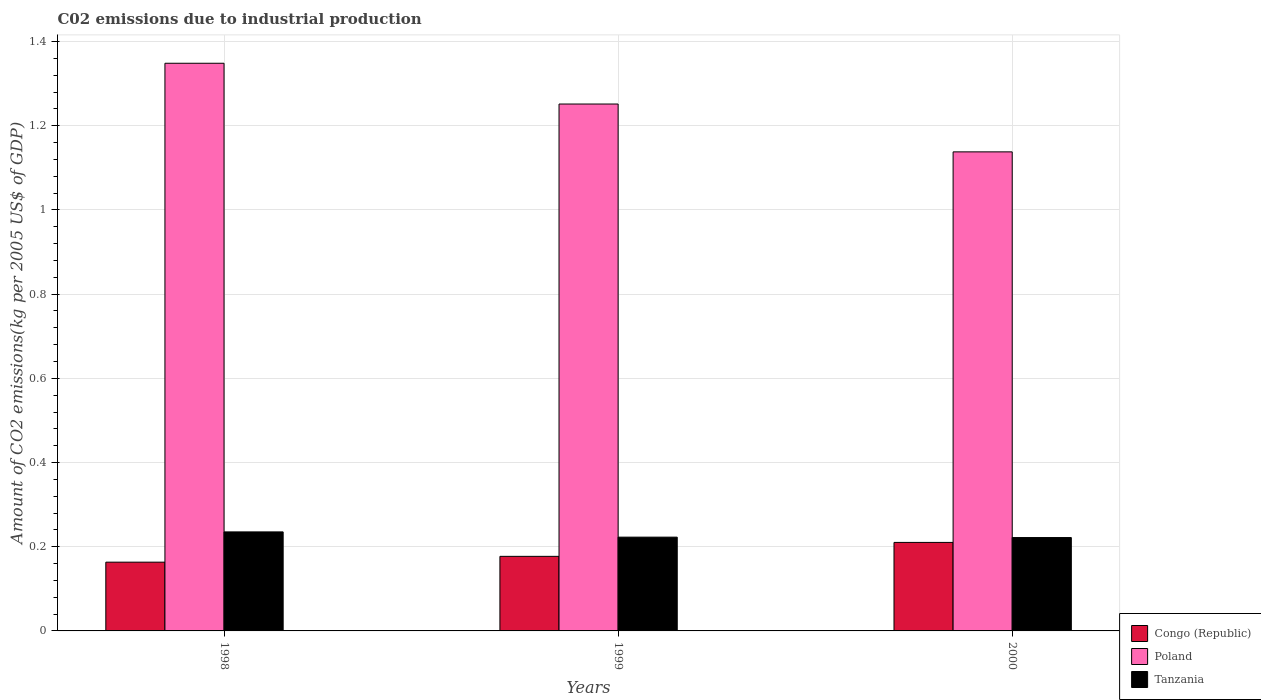Are the number of bars on each tick of the X-axis equal?
Provide a short and direct response. Yes. How many bars are there on the 3rd tick from the right?
Your answer should be compact. 3. What is the amount of CO2 emitted due to industrial production in Poland in 1999?
Offer a terse response. 1.25. Across all years, what is the maximum amount of CO2 emitted due to industrial production in Poland?
Make the answer very short. 1.35. Across all years, what is the minimum amount of CO2 emitted due to industrial production in Poland?
Make the answer very short. 1.14. What is the total amount of CO2 emitted due to industrial production in Tanzania in the graph?
Give a very brief answer. 0.68. What is the difference between the amount of CO2 emitted due to industrial production in Poland in 1998 and that in 1999?
Your answer should be compact. 0.1. What is the difference between the amount of CO2 emitted due to industrial production in Congo (Republic) in 2000 and the amount of CO2 emitted due to industrial production in Poland in 1998?
Provide a short and direct response. -1.14. What is the average amount of CO2 emitted due to industrial production in Poland per year?
Your response must be concise. 1.25. In the year 2000, what is the difference between the amount of CO2 emitted due to industrial production in Tanzania and amount of CO2 emitted due to industrial production in Poland?
Provide a succinct answer. -0.92. In how many years, is the amount of CO2 emitted due to industrial production in Tanzania greater than 0.68 kg?
Ensure brevity in your answer.  0. What is the ratio of the amount of CO2 emitted due to industrial production in Tanzania in 1998 to that in 2000?
Give a very brief answer. 1.06. Is the amount of CO2 emitted due to industrial production in Tanzania in 1998 less than that in 2000?
Ensure brevity in your answer.  No. What is the difference between the highest and the second highest amount of CO2 emitted due to industrial production in Congo (Republic)?
Keep it short and to the point. 0.03. What is the difference between the highest and the lowest amount of CO2 emitted due to industrial production in Tanzania?
Ensure brevity in your answer.  0.01. Is the sum of the amount of CO2 emitted due to industrial production in Poland in 1999 and 2000 greater than the maximum amount of CO2 emitted due to industrial production in Congo (Republic) across all years?
Give a very brief answer. Yes. What does the 1st bar from the left in 1999 represents?
Your answer should be very brief. Congo (Republic). What does the 1st bar from the right in 1998 represents?
Keep it short and to the point. Tanzania. Is it the case that in every year, the sum of the amount of CO2 emitted due to industrial production in Poland and amount of CO2 emitted due to industrial production in Congo (Republic) is greater than the amount of CO2 emitted due to industrial production in Tanzania?
Make the answer very short. Yes. How many bars are there?
Offer a very short reply. 9. How many years are there in the graph?
Give a very brief answer. 3. Does the graph contain any zero values?
Offer a terse response. No. Does the graph contain grids?
Provide a short and direct response. Yes. What is the title of the graph?
Provide a succinct answer. C02 emissions due to industrial production. What is the label or title of the X-axis?
Your answer should be compact. Years. What is the label or title of the Y-axis?
Make the answer very short. Amount of CO2 emissions(kg per 2005 US$ of GDP). What is the Amount of CO2 emissions(kg per 2005 US$ of GDP) in Congo (Republic) in 1998?
Provide a succinct answer. 0.16. What is the Amount of CO2 emissions(kg per 2005 US$ of GDP) of Poland in 1998?
Provide a short and direct response. 1.35. What is the Amount of CO2 emissions(kg per 2005 US$ of GDP) of Tanzania in 1998?
Offer a very short reply. 0.24. What is the Amount of CO2 emissions(kg per 2005 US$ of GDP) of Congo (Republic) in 1999?
Offer a very short reply. 0.18. What is the Amount of CO2 emissions(kg per 2005 US$ of GDP) in Poland in 1999?
Provide a succinct answer. 1.25. What is the Amount of CO2 emissions(kg per 2005 US$ of GDP) of Tanzania in 1999?
Your answer should be compact. 0.22. What is the Amount of CO2 emissions(kg per 2005 US$ of GDP) in Congo (Republic) in 2000?
Make the answer very short. 0.21. What is the Amount of CO2 emissions(kg per 2005 US$ of GDP) of Poland in 2000?
Your answer should be very brief. 1.14. What is the Amount of CO2 emissions(kg per 2005 US$ of GDP) in Tanzania in 2000?
Offer a very short reply. 0.22. Across all years, what is the maximum Amount of CO2 emissions(kg per 2005 US$ of GDP) in Congo (Republic)?
Your response must be concise. 0.21. Across all years, what is the maximum Amount of CO2 emissions(kg per 2005 US$ of GDP) in Poland?
Offer a terse response. 1.35. Across all years, what is the maximum Amount of CO2 emissions(kg per 2005 US$ of GDP) of Tanzania?
Ensure brevity in your answer.  0.24. Across all years, what is the minimum Amount of CO2 emissions(kg per 2005 US$ of GDP) in Congo (Republic)?
Offer a very short reply. 0.16. Across all years, what is the minimum Amount of CO2 emissions(kg per 2005 US$ of GDP) in Poland?
Your answer should be compact. 1.14. Across all years, what is the minimum Amount of CO2 emissions(kg per 2005 US$ of GDP) in Tanzania?
Give a very brief answer. 0.22. What is the total Amount of CO2 emissions(kg per 2005 US$ of GDP) of Congo (Republic) in the graph?
Offer a terse response. 0.55. What is the total Amount of CO2 emissions(kg per 2005 US$ of GDP) in Poland in the graph?
Your answer should be very brief. 3.74. What is the total Amount of CO2 emissions(kg per 2005 US$ of GDP) in Tanzania in the graph?
Your answer should be very brief. 0.68. What is the difference between the Amount of CO2 emissions(kg per 2005 US$ of GDP) in Congo (Republic) in 1998 and that in 1999?
Offer a terse response. -0.01. What is the difference between the Amount of CO2 emissions(kg per 2005 US$ of GDP) in Poland in 1998 and that in 1999?
Provide a succinct answer. 0.1. What is the difference between the Amount of CO2 emissions(kg per 2005 US$ of GDP) of Tanzania in 1998 and that in 1999?
Offer a terse response. 0.01. What is the difference between the Amount of CO2 emissions(kg per 2005 US$ of GDP) in Congo (Republic) in 1998 and that in 2000?
Give a very brief answer. -0.05. What is the difference between the Amount of CO2 emissions(kg per 2005 US$ of GDP) of Poland in 1998 and that in 2000?
Keep it short and to the point. 0.21. What is the difference between the Amount of CO2 emissions(kg per 2005 US$ of GDP) in Tanzania in 1998 and that in 2000?
Keep it short and to the point. 0.01. What is the difference between the Amount of CO2 emissions(kg per 2005 US$ of GDP) of Congo (Republic) in 1999 and that in 2000?
Your answer should be compact. -0.03. What is the difference between the Amount of CO2 emissions(kg per 2005 US$ of GDP) in Poland in 1999 and that in 2000?
Make the answer very short. 0.11. What is the difference between the Amount of CO2 emissions(kg per 2005 US$ of GDP) of Congo (Republic) in 1998 and the Amount of CO2 emissions(kg per 2005 US$ of GDP) of Poland in 1999?
Give a very brief answer. -1.09. What is the difference between the Amount of CO2 emissions(kg per 2005 US$ of GDP) in Congo (Republic) in 1998 and the Amount of CO2 emissions(kg per 2005 US$ of GDP) in Tanzania in 1999?
Offer a terse response. -0.06. What is the difference between the Amount of CO2 emissions(kg per 2005 US$ of GDP) in Poland in 1998 and the Amount of CO2 emissions(kg per 2005 US$ of GDP) in Tanzania in 1999?
Your response must be concise. 1.13. What is the difference between the Amount of CO2 emissions(kg per 2005 US$ of GDP) in Congo (Republic) in 1998 and the Amount of CO2 emissions(kg per 2005 US$ of GDP) in Poland in 2000?
Your answer should be compact. -0.97. What is the difference between the Amount of CO2 emissions(kg per 2005 US$ of GDP) of Congo (Republic) in 1998 and the Amount of CO2 emissions(kg per 2005 US$ of GDP) of Tanzania in 2000?
Your answer should be very brief. -0.06. What is the difference between the Amount of CO2 emissions(kg per 2005 US$ of GDP) in Poland in 1998 and the Amount of CO2 emissions(kg per 2005 US$ of GDP) in Tanzania in 2000?
Your answer should be compact. 1.13. What is the difference between the Amount of CO2 emissions(kg per 2005 US$ of GDP) in Congo (Republic) in 1999 and the Amount of CO2 emissions(kg per 2005 US$ of GDP) in Poland in 2000?
Provide a short and direct response. -0.96. What is the difference between the Amount of CO2 emissions(kg per 2005 US$ of GDP) in Congo (Republic) in 1999 and the Amount of CO2 emissions(kg per 2005 US$ of GDP) in Tanzania in 2000?
Your answer should be compact. -0.04. What is the difference between the Amount of CO2 emissions(kg per 2005 US$ of GDP) in Poland in 1999 and the Amount of CO2 emissions(kg per 2005 US$ of GDP) in Tanzania in 2000?
Your answer should be very brief. 1.03. What is the average Amount of CO2 emissions(kg per 2005 US$ of GDP) of Congo (Republic) per year?
Provide a succinct answer. 0.18. What is the average Amount of CO2 emissions(kg per 2005 US$ of GDP) of Poland per year?
Give a very brief answer. 1.25. What is the average Amount of CO2 emissions(kg per 2005 US$ of GDP) of Tanzania per year?
Provide a short and direct response. 0.23. In the year 1998, what is the difference between the Amount of CO2 emissions(kg per 2005 US$ of GDP) in Congo (Republic) and Amount of CO2 emissions(kg per 2005 US$ of GDP) in Poland?
Keep it short and to the point. -1.19. In the year 1998, what is the difference between the Amount of CO2 emissions(kg per 2005 US$ of GDP) in Congo (Republic) and Amount of CO2 emissions(kg per 2005 US$ of GDP) in Tanzania?
Your answer should be very brief. -0.07. In the year 1998, what is the difference between the Amount of CO2 emissions(kg per 2005 US$ of GDP) of Poland and Amount of CO2 emissions(kg per 2005 US$ of GDP) of Tanzania?
Keep it short and to the point. 1.11. In the year 1999, what is the difference between the Amount of CO2 emissions(kg per 2005 US$ of GDP) of Congo (Republic) and Amount of CO2 emissions(kg per 2005 US$ of GDP) of Poland?
Offer a very short reply. -1.07. In the year 1999, what is the difference between the Amount of CO2 emissions(kg per 2005 US$ of GDP) in Congo (Republic) and Amount of CO2 emissions(kg per 2005 US$ of GDP) in Tanzania?
Your answer should be compact. -0.05. In the year 1999, what is the difference between the Amount of CO2 emissions(kg per 2005 US$ of GDP) in Poland and Amount of CO2 emissions(kg per 2005 US$ of GDP) in Tanzania?
Offer a very short reply. 1.03. In the year 2000, what is the difference between the Amount of CO2 emissions(kg per 2005 US$ of GDP) in Congo (Republic) and Amount of CO2 emissions(kg per 2005 US$ of GDP) in Poland?
Ensure brevity in your answer.  -0.93. In the year 2000, what is the difference between the Amount of CO2 emissions(kg per 2005 US$ of GDP) in Congo (Republic) and Amount of CO2 emissions(kg per 2005 US$ of GDP) in Tanzania?
Offer a very short reply. -0.01. In the year 2000, what is the difference between the Amount of CO2 emissions(kg per 2005 US$ of GDP) in Poland and Amount of CO2 emissions(kg per 2005 US$ of GDP) in Tanzania?
Ensure brevity in your answer.  0.92. What is the ratio of the Amount of CO2 emissions(kg per 2005 US$ of GDP) of Congo (Republic) in 1998 to that in 1999?
Keep it short and to the point. 0.92. What is the ratio of the Amount of CO2 emissions(kg per 2005 US$ of GDP) in Poland in 1998 to that in 1999?
Your answer should be very brief. 1.08. What is the ratio of the Amount of CO2 emissions(kg per 2005 US$ of GDP) of Tanzania in 1998 to that in 1999?
Provide a short and direct response. 1.06. What is the ratio of the Amount of CO2 emissions(kg per 2005 US$ of GDP) in Congo (Republic) in 1998 to that in 2000?
Give a very brief answer. 0.78. What is the ratio of the Amount of CO2 emissions(kg per 2005 US$ of GDP) of Poland in 1998 to that in 2000?
Provide a short and direct response. 1.19. What is the ratio of the Amount of CO2 emissions(kg per 2005 US$ of GDP) of Tanzania in 1998 to that in 2000?
Your answer should be very brief. 1.06. What is the ratio of the Amount of CO2 emissions(kg per 2005 US$ of GDP) of Congo (Republic) in 1999 to that in 2000?
Your response must be concise. 0.84. What is the ratio of the Amount of CO2 emissions(kg per 2005 US$ of GDP) in Poland in 1999 to that in 2000?
Provide a short and direct response. 1.1. What is the difference between the highest and the second highest Amount of CO2 emissions(kg per 2005 US$ of GDP) in Congo (Republic)?
Keep it short and to the point. 0.03. What is the difference between the highest and the second highest Amount of CO2 emissions(kg per 2005 US$ of GDP) in Poland?
Make the answer very short. 0.1. What is the difference between the highest and the second highest Amount of CO2 emissions(kg per 2005 US$ of GDP) of Tanzania?
Your answer should be compact. 0.01. What is the difference between the highest and the lowest Amount of CO2 emissions(kg per 2005 US$ of GDP) in Congo (Republic)?
Ensure brevity in your answer.  0.05. What is the difference between the highest and the lowest Amount of CO2 emissions(kg per 2005 US$ of GDP) in Poland?
Offer a very short reply. 0.21. What is the difference between the highest and the lowest Amount of CO2 emissions(kg per 2005 US$ of GDP) in Tanzania?
Your answer should be very brief. 0.01. 